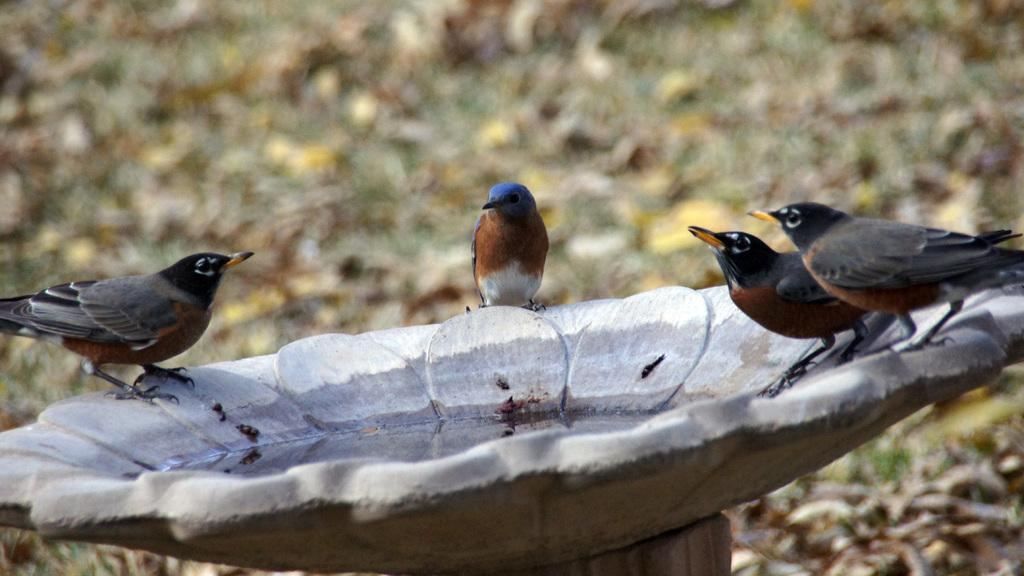What type of animals can be seen on the surface in the image? There are birds on the surface in the image. What is the primary element visible in the image? There is water visible in the image. What can be seen in the background of the image? Dried leaves and grass are visible in the background of the image. Where is the basketball located in the image? There is no basketball present in the image. Can you see any ladybugs on the grass in the image? There is no mention of ladybugs in the image, only birds and dried leaves are mentioned. 